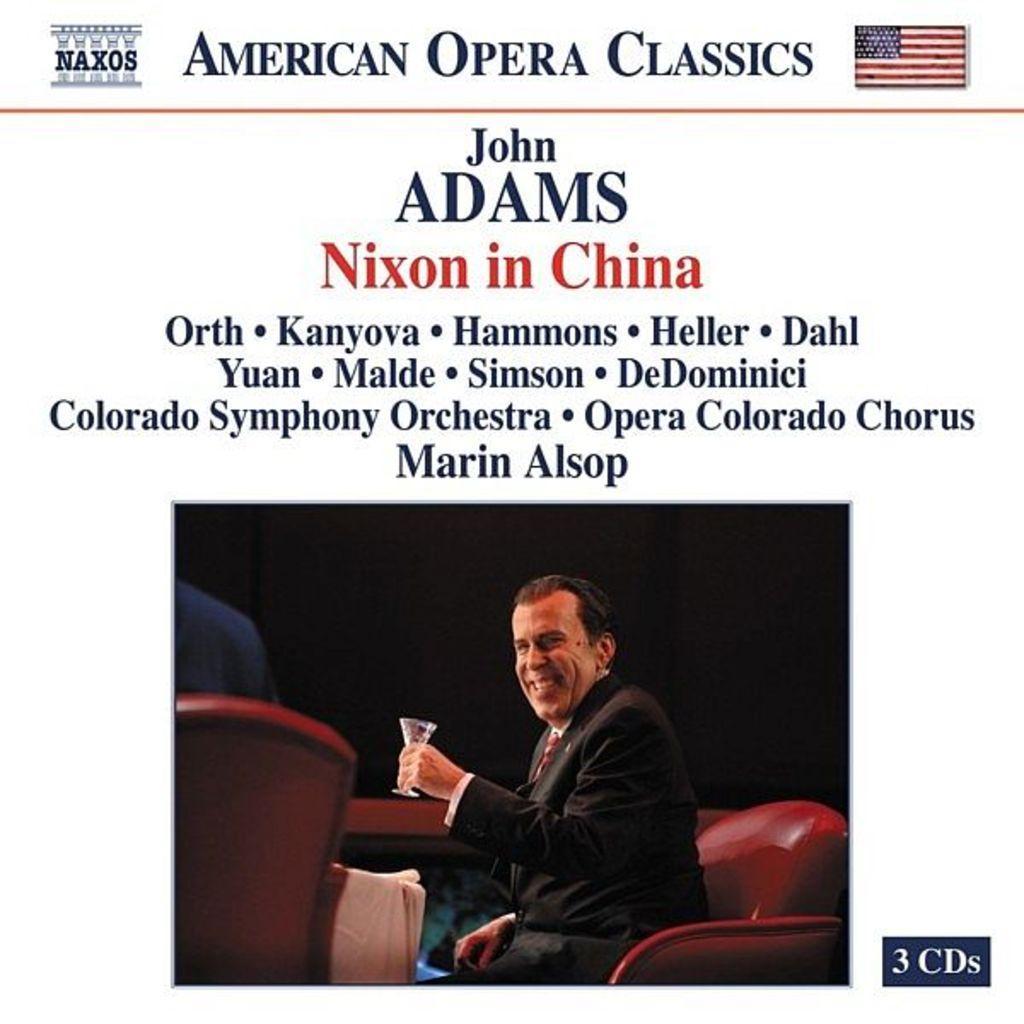In one or two sentences, can you explain what this image depicts? It looks like a page inside magazine there is something written like American Opera classics on the top and also there is American flag decide it the picture inside the page there is a man sitting on the Sofa he is holding glass in his hand he is also laughing ,the background is black color. 